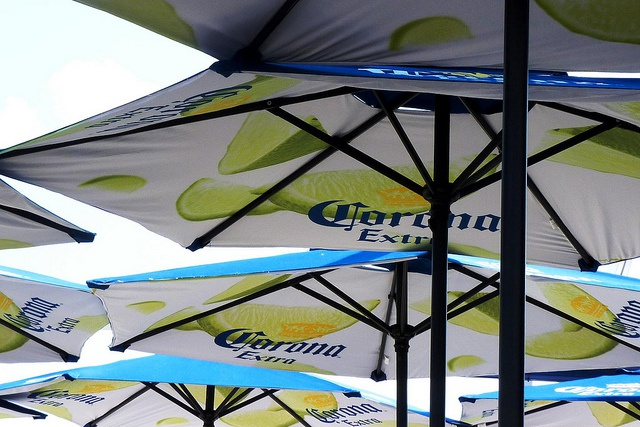Describe the objects in this image and their specific colors. I can see umbrella in white, darkgray, black, gray, and olive tones, umbrella in white, darkgray, black, and olive tones, umbrella in white, black, gray, and darkgreen tones, umbrella in white, lightgray, black, and lightblue tones, and umbrella in white, darkgray, and lightblue tones in this image. 